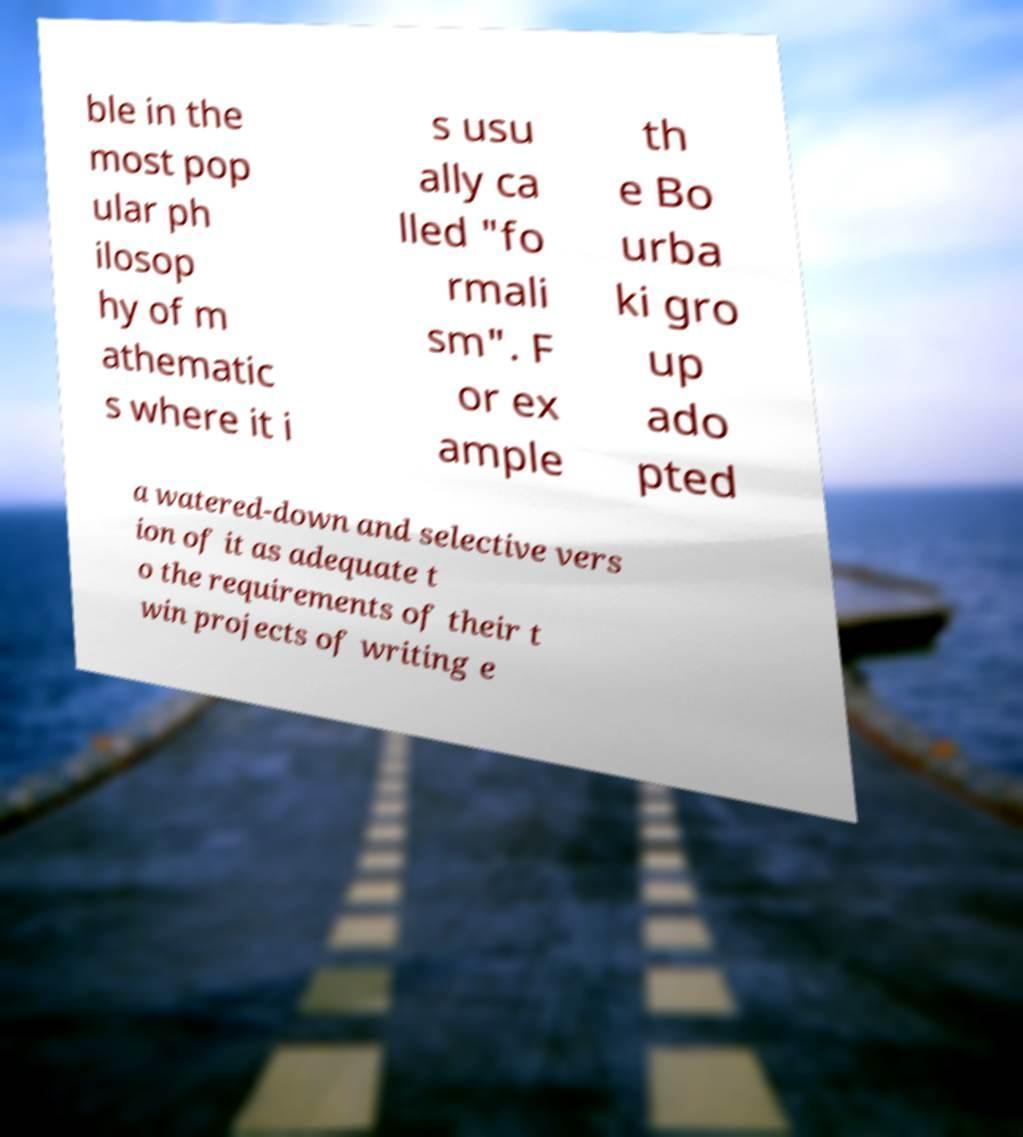Could you extract and type out the text from this image? ble in the most pop ular ph ilosop hy of m athematic s where it i s usu ally ca lled "fo rmali sm". F or ex ample th e Bo urba ki gro up ado pted a watered-down and selective vers ion of it as adequate t o the requirements of their t win projects of writing e 